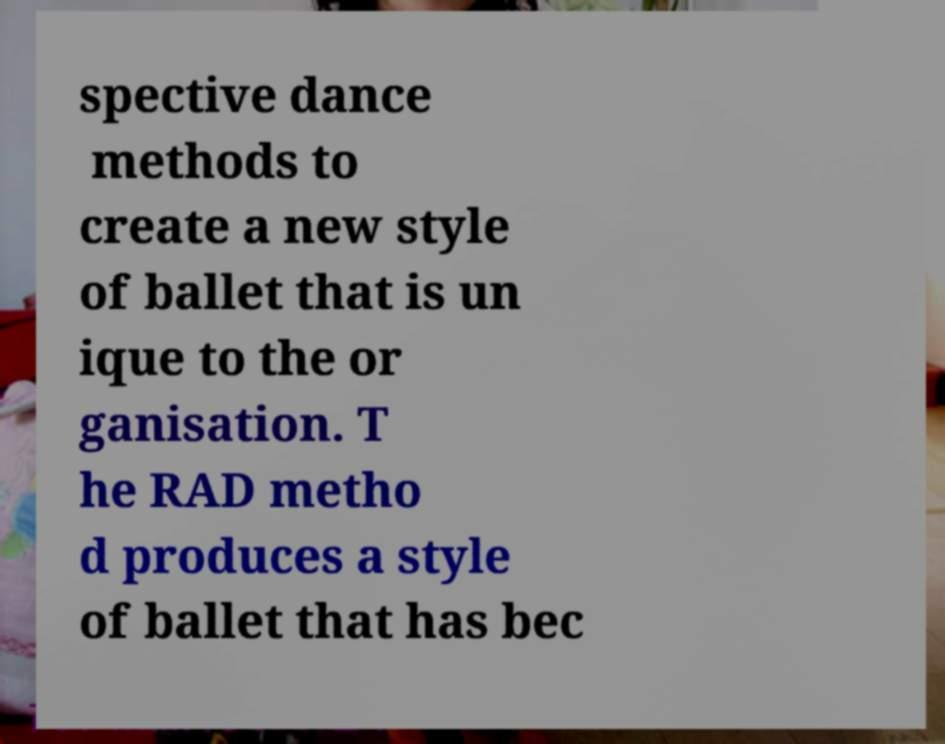I need the written content from this picture converted into text. Can you do that? spective dance methods to create a new style of ballet that is un ique to the or ganisation. T he RAD metho d produces a style of ballet that has bec 